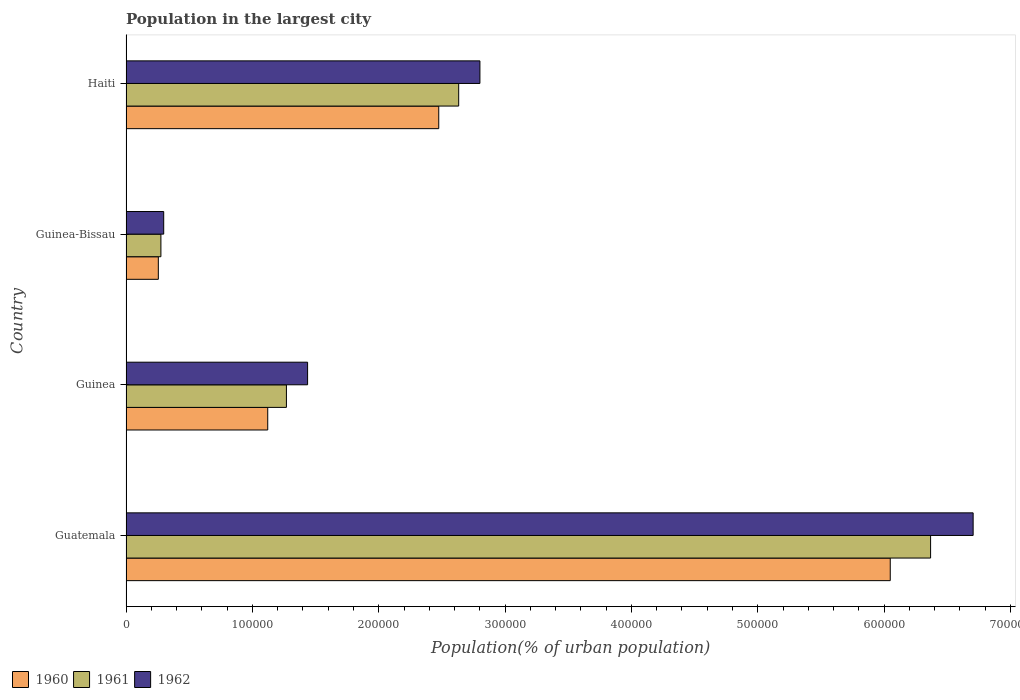How many different coloured bars are there?
Your answer should be very brief. 3. How many groups of bars are there?
Make the answer very short. 4. How many bars are there on the 1st tick from the top?
Offer a terse response. 3. How many bars are there on the 2nd tick from the bottom?
Offer a terse response. 3. What is the label of the 2nd group of bars from the top?
Your answer should be very brief. Guinea-Bissau. What is the population in the largest city in 1962 in Guinea-Bissau?
Ensure brevity in your answer.  2.98e+04. Across all countries, what is the maximum population in the largest city in 1961?
Keep it short and to the point. 6.37e+05. Across all countries, what is the minimum population in the largest city in 1960?
Ensure brevity in your answer.  2.56e+04. In which country was the population in the largest city in 1960 maximum?
Offer a very short reply. Guatemala. In which country was the population in the largest city in 1962 minimum?
Provide a succinct answer. Guinea-Bissau. What is the total population in the largest city in 1962 in the graph?
Offer a terse response. 1.12e+06. What is the difference between the population in the largest city in 1961 in Guatemala and that in Guinea-Bissau?
Your answer should be very brief. 6.09e+05. What is the difference between the population in the largest city in 1961 in Guinea-Bissau and the population in the largest city in 1960 in Haiti?
Provide a succinct answer. -2.20e+05. What is the average population in the largest city in 1961 per country?
Your answer should be compact. 2.64e+05. What is the difference between the population in the largest city in 1960 and population in the largest city in 1962 in Guinea-Bissau?
Offer a terse response. -4261. In how many countries, is the population in the largest city in 1960 greater than 680000 %?
Offer a terse response. 0. What is the ratio of the population in the largest city in 1961 in Guinea to that in Guinea-Bissau?
Ensure brevity in your answer.  4.6. What is the difference between the highest and the second highest population in the largest city in 1960?
Provide a short and direct response. 3.57e+05. What is the difference between the highest and the lowest population in the largest city in 1962?
Your answer should be very brief. 6.41e+05. In how many countries, is the population in the largest city in 1962 greater than the average population in the largest city in 1962 taken over all countries?
Your answer should be compact. 1. What does the 2nd bar from the top in Haiti represents?
Ensure brevity in your answer.  1961. Is it the case that in every country, the sum of the population in the largest city in 1962 and population in the largest city in 1961 is greater than the population in the largest city in 1960?
Keep it short and to the point. Yes. How many bars are there?
Your response must be concise. 12. How many countries are there in the graph?
Provide a short and direct response. 4. What is the difference between two consecutive major ticks on the X-axis?
Ensure brevity in your answer.  1.00e+05. Does the graph contain any zero values?
Ensure brevity in your answer.  No. Does the graph contain grids?
Give a very brief answer. No. How many legend labels are there?
Ensure brevity in your answer.  3. What is the title of the graph?
Give a very brief answer. Population in the largest city. What is the label or title of the X-axis?
Your response must be concise. Population(% of urban population). What is the Population(% of urban population) of 1960 in Guatemala?
Your answer should be very brief. 6.05e+05. What is the Population(% of urban population) of 1961 in Guatemala?
Offer a terse response. 6.37e+05. What is the Population(% of urban population) in 1962 in Guatemala?
Your response must be concise. 6.70e+05. What is the Population(% of urban population) in 1960 in Guinea?
Provide a succinct answer. 1.12e+05. What is the Population(% of urban population) of 1961 in Guinea?
Your response must be concise. 1.27e+05. What is the Population(% of urban population) in 1962 in Guinea?
Offer a very short reply. 1.44e+05. What is the Population(% of urban population) in 1960 in Guinea-Bissau?
Offer a terse response. 2.56e+04. What is the Population(% of urban population) of 1961 in Guinea-Bissau?
Your answer should be compact. 2.76e+04. What is the Population(% of urban population) in 1962 in Guinea-Bissau?
Provide a short and direct response. 2.98e+04. What is the Population(% of urban population) of 1960 in Haiti?
Provide a short and direct response. 2.47e+05. What is the Population(% of urban population) of 1961 in Haiti?
Provide a succinct answer. 2.63e+05. What is the Population(% of urban population) in 1962 in Haiti?
Give a very brief answer. 2.80e+05. Across all countries, what is the maximum Population(% of urban population) in 1960?
Your answer should be compact. 6.05e+05. Across all countries, what is the maximum Population(% of urban population) in 1961?
Your response must be concise. 6.37e+05. Across all countries, what is the maximum Population(% of urban population) of 1962?
Provide a succinct answer. 6.70e+05. Across all countries, what is the minimum Population(% of urban population) of 1960?
Offer a terse response. 2.56e+04. Across all countries, what is the minimum Population(% of urban population) in 1961?
Ensure brevity in your answer.  2.76e+04. Across all countries, what is the minimum Population(% of urban population) of 1962?
Make the answer very short. 2.98e+04. What is the total Population(% of urban population) of 1960 in the graph?
Provide a short and direct response. 9.90e+05. What is the total Population(% of urban population) of 1961 in the graph?
Provide a succinct answer. 1.05e+06. What is the total Population(% of urban population) of 1962 in the graph?
Offer a very short reply. 1.12e+06. What is the difference between the Population(% of urban population) in 1960 in Guatemala and that in Guinea?
Your answer should be very brief. 4.93e+05. What is the difference between the Population(% of urban population) of 1961 in Guatemala and that in Guinea?
Provide a short and direct response. 5.10e+05. What is the difference between the Population(% of urban population) in 1962 in Guatemala and that in Guinea?
Ensure brevity in your answer.  5.27e+05. What is the difference between the Population(% of urban population) in 1960 in Guatemala and that in Guinea-Bissau?
Your response must be concise. 5.79e+05. What is the difference between the Population(% of urban population) in 1961 in Guatemala and that in Guinea-Bissau?
Make the answer very short. 6.09e+05. What is the difference between the Population(% of urban population) of 1962 in Guatemala and that in Guinea-Bissau?
Ensure brevity in your answer.  6.41e+05. What is the difference between the Population(% of urban population) in 1960 in Guatemala and that in Haiti?
Your response must be concise. 3.57e+05. What is the difference between the Population(% of urban population) in 1961 in Guatemala and that in Haiti?
Your answer should be very brief. 3.73e+05. What is the difference between the Population(% of urban population) in 1962 in Guatemala and that in Haiti?
Give a very brief answer. 3.90e+05. What is the difference between the Population(% of urban population) of 1960 in Guinea and that in Guinea-Bissau?
Your answer should be compact. 8.66e+04. What is the difference between the Population(% of urban population) in 1961 in Guinea and that in Guinea-Bissau?
Your answer should be very brief. 9.93e+04. What is the difference between the Population(% of urban population) of 1962 in Guinea and that in Guinea-Bissau?
Keep it short and to the point. 1.14e+05. What is the difference between the Population(% of urban population) of 1960 in Guinea and that in Haiti?
Ensure brevity in your answer.  -1.35e+05. What is the difference between the Population(% of urban population) in 1961 in Guinea and that in Haiti?
Your response must be concise. -1.36e+05. What is the difference between the Population(% of urban population) of 1962 in Guinea and that in Haiti?
Make the answer very short. -1.36e+05. What is the difference between the Population(% of urban population) in 1960 in Guinea-Bissau and that in Haiti?
Provide a short and direct response. -2.22e+05. What is the difference between the Population(% of urban population) of 1961 in Guinea-Bissau and that in Haiti?
Make the answer very short. -2.36e+05. What is the difference between the Population(% of urban population) of 1962 in Guinea-Bissau and that in Haiti?
Keep it short and to the point. -2.50e+05. What is the difference between the Population(% of urban population) in 1960 in Guatemala and the Population(% of urban population) in 1961 in Guinea?
Provide a succinct answer. 4.78e+05. What is the difference between the Population(% of urban population) in 1960 in Guatemala and the Population(% of urban population) in 1962 in Guinea?
Your answer should be very brief. 4.61e+05. What is the difference between the Population(% of urban population) in 1961 in Guatemala and the Population(% of urban population) in 1962 in Guinea?
Keep it short and to the point. 4.93e+05. What is the difference between the Population(% of urban population) in 1960 in Guatemala and the Population(% of urban population) in 1961 in Guinea-Bissau?
Your response must be concise. 5.77e+05. What is the difference between the Population(% of urban population) in 1960 in Guatemala and the Population(% of urban population) in 1962 in Guinea-Bissau?
Offer a very short reply. 5.75e+05. What is the difference between the Population(% of urban population) of 1961 in Guatemala and the Population(% of urban population) of 1962 in Guinea-Bissau?
Your answer should be compact. 6.07e+05. What is the difference between the Population(% of urban population) of 1960 in Guatemala and the Population(% of urban population) of 1961 in Haiti?
Provide a short and direct response. 3.42e+05. What is the difference between the Population(% of urban population) in 1960 in Guatemala and the Population(% of urban population) in 1962 in Haiti?
Your answer should be very brief. 3.25e+05. What is the difference between the Population(% of urban population) in 1961 in Guatemala and the Population(% of urban population) in 1962 in Haiti?
Keep it short and to the point. 3.57e+05. What is the difference between the Population(% of urban population) in 1960 in Guinea and the Population(% of urban population) in 1961 in Guinea-Bissau?
Your answer should be compact. 8.45e+04. What is the difference between the Population(% of urban population) in 1960 in Guinea and the Population(% of urban population) in 1962 in Guinea-Bissau?
Give a very brief answer. 8.23e+04. What is the difference between the Population(% of urban population) in 1961 in Guinea and the Population(% of urban population) in 1962 in Guinea-Bissau?
Your response must be concise. 9.71e+04. What is the difference between the Population(% of urban population) in 1960 in Guinea and the Population(% of urban population) in 1961 in Haiti?
Provide a succinct answer. -1.51e+05. What is the difference between the Population(% of urban population) in 1960 in Guinea and the Population(% of urban population) in 1962 in Haiti?
Your answer should be compact. -1.68e+05. What is the difference between the Population(% of urban population) in 1961 in Guinea and the Population(% of urban population) in 1962 in Haiti?
Give a very brief answer. -1.53e+05. What is the difference between the Population(% of urban population) of 1960 in Guinea-Bissau and the Population(% of urban population) of 1961 in Haiti?
Offer a terse response. -2.38e+05. What is the difference between the Population(% of urban population) in 1960 in Guinea-Bissau and the Population(% of urban population) in 1962 in Haiti?
Your answer should be compact. -2.55e+05. What is the difference between the Population(% of urban population) in 1961 in Guinea-Bissau and the Population(% of urban population) in 1962 in Haiti?
Offer a very short reply. -2.52e+05. What is the average Population(% of urban population) of 1960 per country?
Provide a succinct answer. 2.48e+05. What is the average Population(% of urban population) in 1961 per country?
Your response must be concise. 2.64e+05. What is the average Population(% of urban population) in 1962 per country?
Provide a succinct answer. 2.81e+05. What is the difference between the Population(% of urban population) in 1960 and Population(% of urban population) in 1961 in Guatemala?
Your answer should be compact. -3.19e+04. What is the difference between the Population(% of urban population) in 1960 and Population(% of urban population) in 1962 in Guatemala?
Give a very brief answer. -6.56e+04. What is the difference between the Population(% of urban population) in 1961 and Population(% of urban population) in 1962 in Guatemala?
Your answer should be very brief. -3.37e+04. What is the difference between the Population(% of urban population) in 1960 and Population(% of urban population) in 1961 in Guinea?
Your response must be concise. -1.48e+04. What is the difference between the Population(% of urban population) of 1960 and Population(% of urban population) of 1962 in Guinea?
Provide a short and direct response. -3.15e+04. What is the difference between the Population(% of urban population) in 1961 and Population(% of urban population) in 1962 in Guinea?
Your answer should be very brief. -1.68e+04. What is the difference between the Population(% of urban population) of 1960 and Population(% of urban population) of 1961 in Guinea-Bissau?
Ensure brevity in your answer.  -2047. What is the difference between the Population(% of urban population) in 1960 and Population(% of urban population) in 1962 in Guinea-Bissau?
Your answer should be very brief. -4261. What is the difference between the Population(% of urban population) in 1961 and Population(% of urban population) in 1962 in Guinea-Bissau?
Your answer should be very brief. -2214. What is the difference between the Population(% of urban population) of 1960 and Population(% of urban population) of 1961 in Haiti?
Offer a terse response. -1.58e+04. What is the difference between the Population(% of urban population) of 1960 and Population(% of urban population) of 1962 in Haiti?
Give a very brief answer. -3.26e+04. What is the difference between the Population(% of urban population) of 1961 and Population(% of urban population) of 1962 in Haiti?
Your response must be concise. -1.68e+04. What is the ratio of the Population(% of urban population) in 1960 in Guatemala to that in Guinea?
Ensure brevity in your answer.  5.39. What is the ratio of the Population(% of urban population) of 1961 in Guatemala to that in Guinea?
Offer a very short reply. 5.02. What is the ratio of the Population(% of urban population) in 1962 in Guatemala to that in Guinea?
Give a very brief answer. 4.67. What is the ratio of the Population(% of urban population) in 1960 in Guatemala to that in Guinea-Bissau?
Offer a very short reply. 23.65. What is the ratio of the Population(% of urban population) in 1961 in Guatemala to that in Guinea-Bissau?
Ensure brevity in your answer.  23.06. What is the ratio of the Population(% of urban population) in 1962 in Guatemala to that in Guinea-Bissau?
Your response must be concise. 22.47. What is the ratio of the Population(% of urban population) in 1960 in Guatemala to that in Haiti?
Provide a short and direct response. 2.44. What is the ratio of the Population(% of urban population) of 1961 in Guatemala to that in Haiti?
Keep it short and to the point. 2.42. What is the ratio of the Population(% of urban population) in 1962 in Guatemala to that in Haiti?
Make the answer very short. 2.39. What is the ratio of the Population(% of urban population) of 1960 in Guinea to that in Guinea-Bissau?
Make the answer very short. 4.39. What is the ratio of the Population(% of urban population) of 1961 in Guinea to that in Guinea-Bissau?
Make the answer very short. 4.6. What is the ratio of the Population(% of urban population) in 1962 in Guinea to that in Guinea-Bissau?
Your answer should be compact. 4.82. What is the ratio of the Population(% of urban population) of 1960 in Guinea to that in Haiti?
Provide a succinct answer. 0.45. What is the ratio of the Population(% of urban population) of 1961 in Guinea to that in Haiti?
Keep it short and to the point. 0.48. What is the ratio of the Population(% of urban population) in 1962 in Guinea to that in Haiti?
Ensure brevity in your answer.  0.51. What is the ratio of the Population(% of urban population) of 1960 in Guinea-Bissau to that in Haiti?
Ensure brevity in your answer.  0.1. What is the ratio of the Population(% of urban population) of 1961 in Guinea-Bissau to that in Haiti?
Your answer should be compact. 0.1. What is the ratio of the Population(% of urban population) of 1962 in Guinea-Bissau to that in Haiti?
Offer a terse response. 0.11. What is the difference between the highest and the second highest Population(% of urban population) of 1960?
Make the answer very short. 3.57e+05. What is the difference between the highest and the second highest Population(% of urban population) of 1961?
Provide a short and direct response. 3.73e+05. What is the difference between the highest and the second highest Population(% of urban population) of 1962?
Give a very brief answer. 3.90e+05. What is the difference between the highest and the lowest Population(% of urban population) of 1960?
Your answer should be compact. 5.79e+05. What is the difference between the highest and the lowest Population(% of urban population) in 1961?
Your answer should be compact. 6.09e+05. What is the difference between the highest and the lowest Population(% of urban population) in 1962?
Make the answer very short. 6.41e+05. 